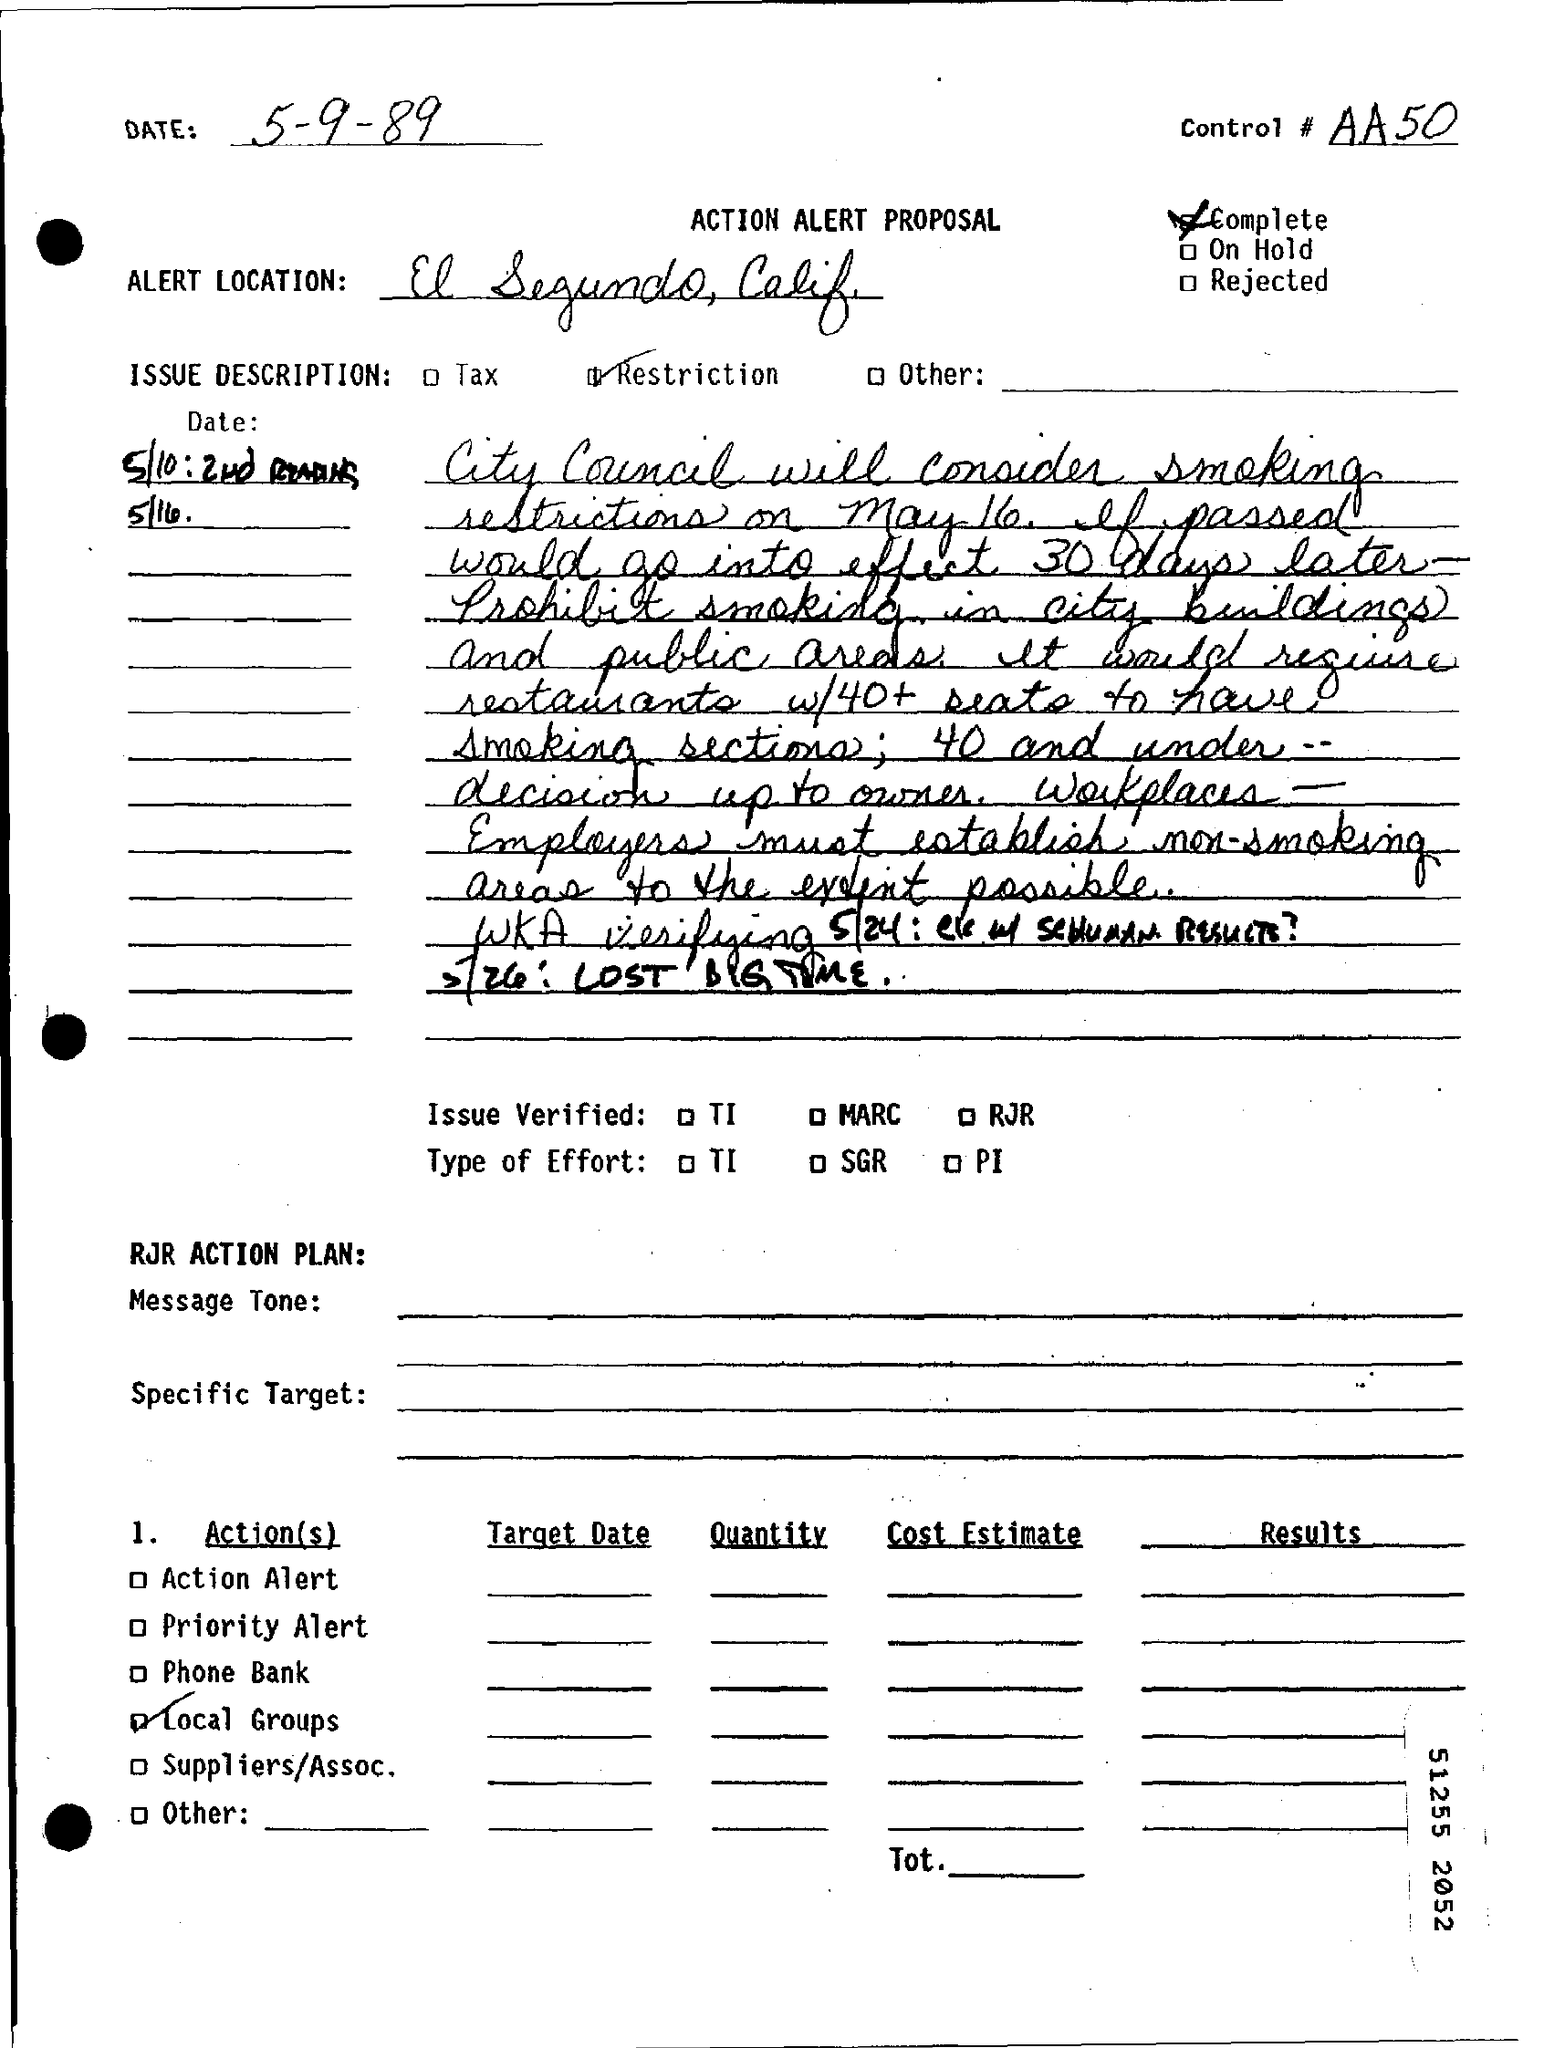What is the date of the document?
Your answer should be compact. 5-9-89. What is control#
Your answer should be very brief. AA50. 